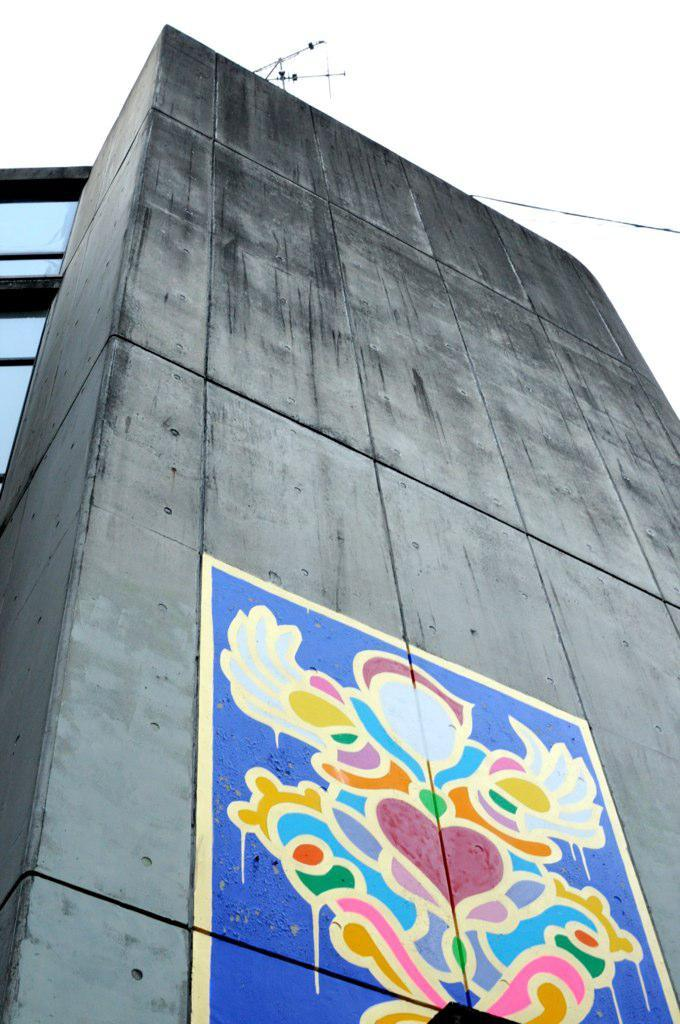What is the main feature of the wall in the image? There is a long grey color cement wall in the image. What is attached to the wall? A colorful design poster is stick on the wall. What can be seen above the wall in the image? The sky is visible above the wall. What is the condition of the sky in the image? The sky is clear in the image. What time is the good-bye message written on the wall in the image? There is no good-bye message present on the wall in the image. What type of watch can be seen on the wall in the image? There is no watch present on the wall in the image. 